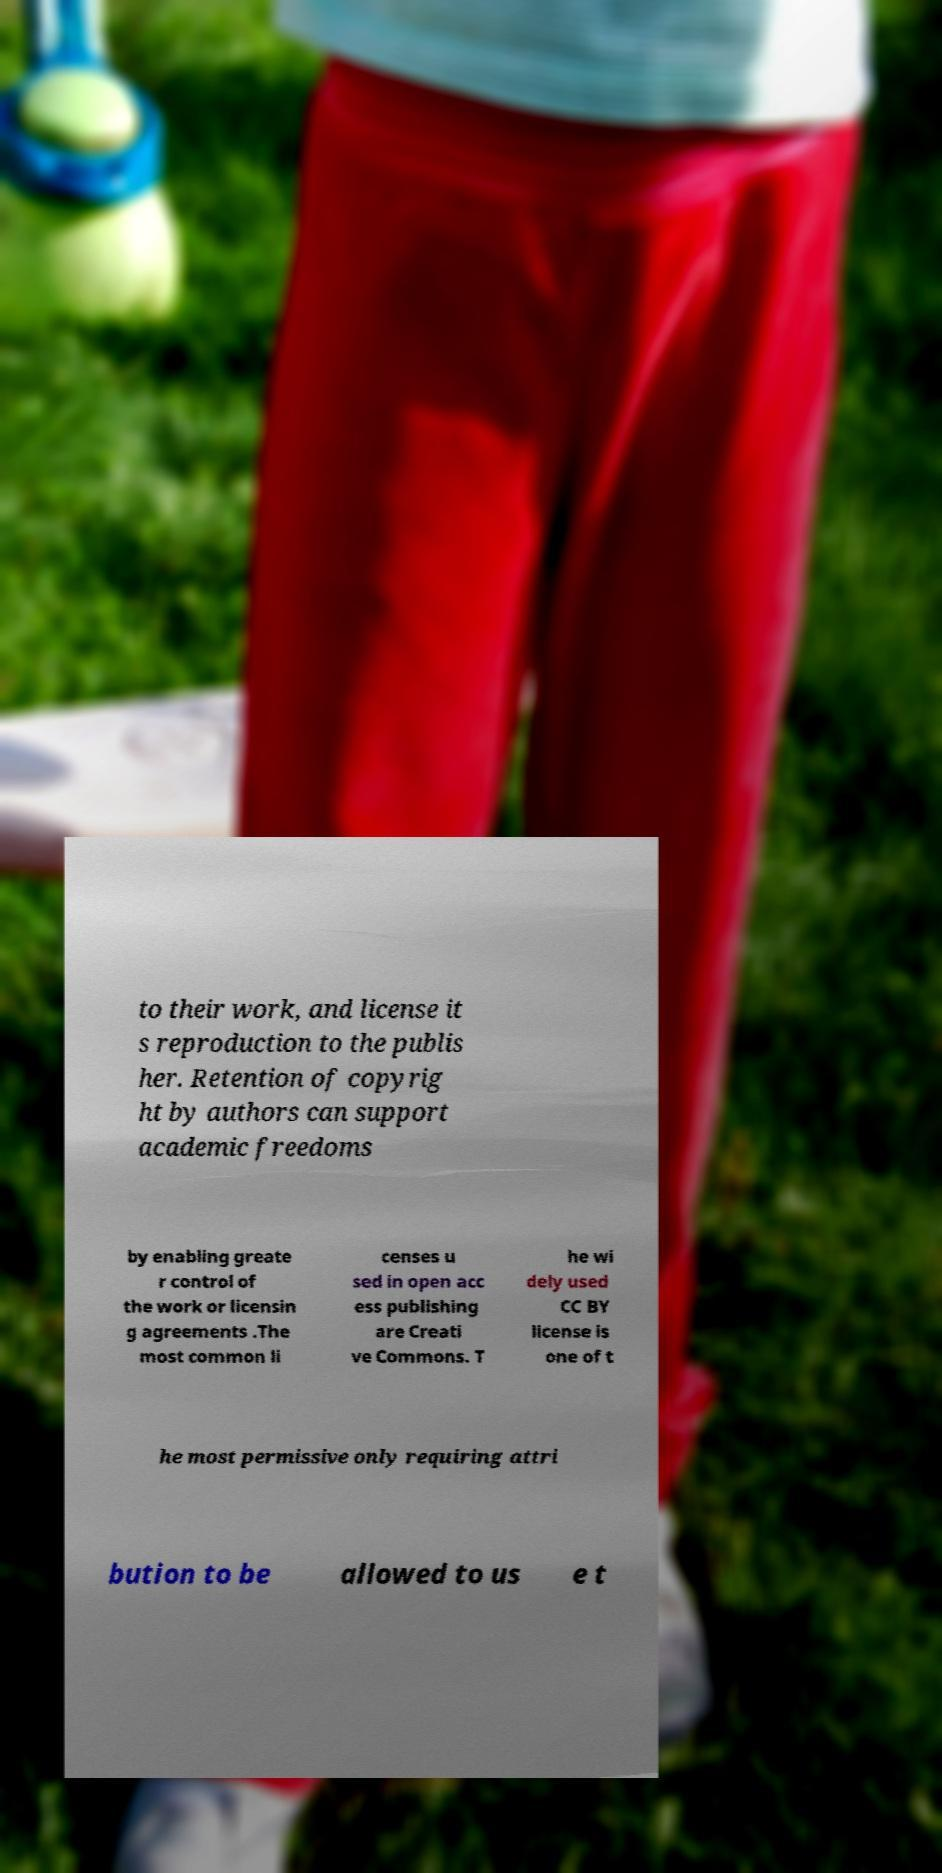Could you assist in decoding the text presented in this image and type it out clearly? to their work, and license it s reproduction to the publis her. Retention of copyrig ht by authors can support academic freedoms by enabling greate r control of the work or licensin g agreements .The most common li censes u sed in open acc ess publishing are Creati ve Commons. T he wi dely used CC BY license is one of t he most permissive only requiring attri bution to be allowed to us e t 